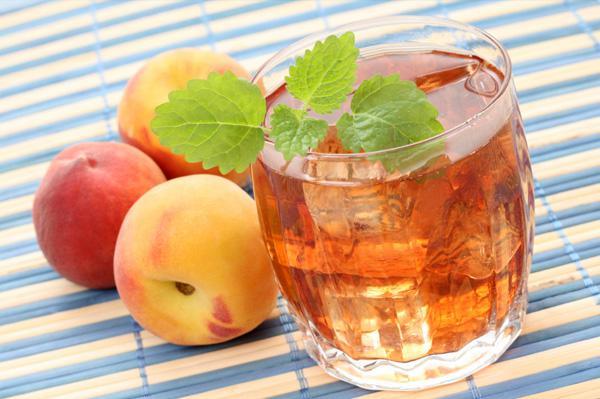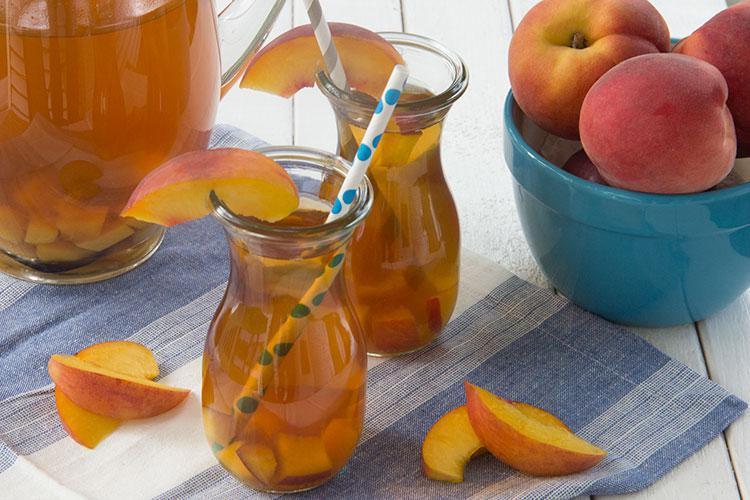The first image is the image on the left, the second image is the image on the right. Considering the images on both sides, is "The left image features a beverage in a jar-type glass with a handle, and the beverage has a straw in it and a green leaf for garnish." valid? Answer yes or no. No. The first image is the image on the left, the second image is the image on the right. Given the left and right images, does the statement "One straw is at least partly red." hold true? Answer yes or no. No. 